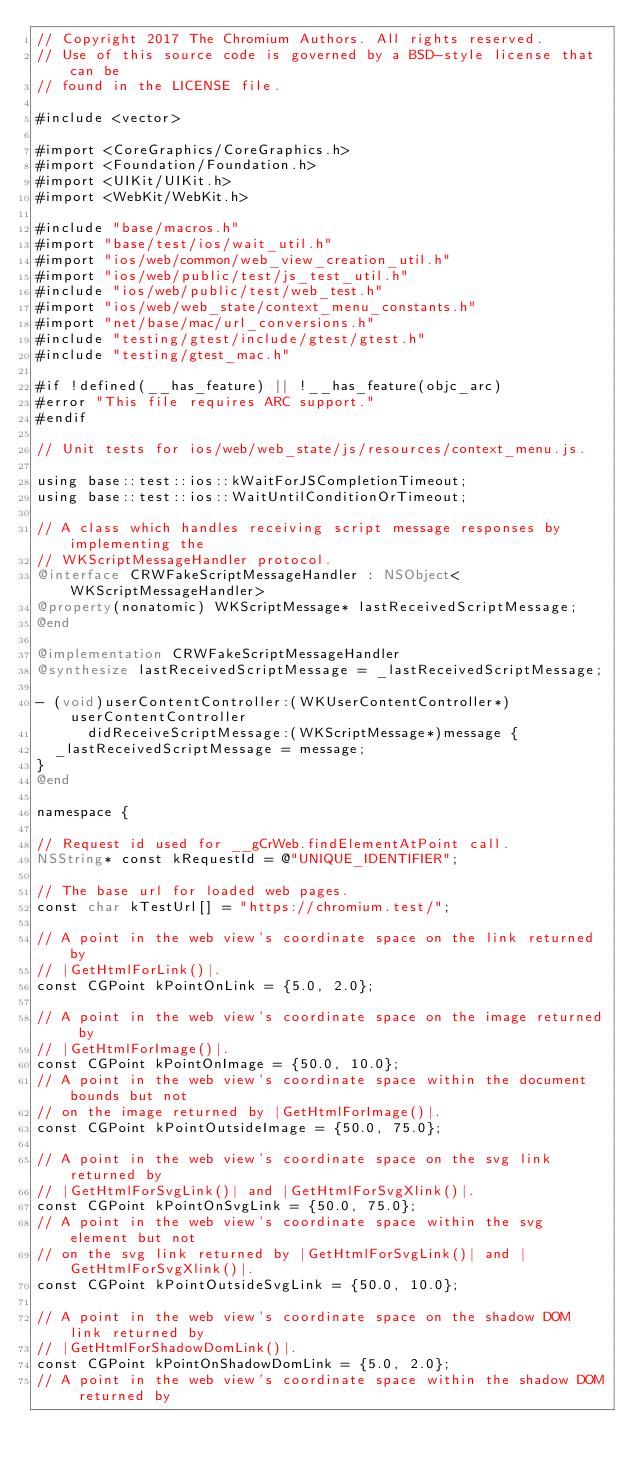<code> <loc_0><loc_0><loc_500><loc_500><_ObjectiveC_>// Copyright 2017 The Chromium Authors. All rights reserved.
// Use of this source code is governed by a BSD-style license that can be
// found in the LICENSE file.

#include <vector>

#import <CoreGraphics/CoreGraphics.h>
#import <Foundation/Foundation.h>
#import <UIKit/UIKit.h>
#import <WebKit/WebKit.h>

#include "base/macros.h"
#import "base/test/ios/wait_util.h"
#import "ios/web/common/web_view_creation_util.h"
#import "ios/web/public/test/js_test_util.h"
#include "ios/web/public/test/web_test.h"
#import "ios/web/web_state/context_menu_constants.h"
#import "net/base/mac/url_conversions.h"
#include "testing/gtest/include/gtest/gtest.h"
#include "testing/gtest_mac.h"

#if !defined(__has_feature) || !__has_feature(objc_arc)
#error "This file requires ARC support."
#endif

// Unit tests for ios/web/web_state/js/resources/context_menu.js.

using base::test::ios::kWaitForJSCompletionTimeout;
using base::test::ios::WaitUntilConditionOrTimeout;

// A class which handles receiving script message responses by implementing the
// WKScriptMessageHandler protocol.
@interface CRWFakeScriptMessageHandler : NSObject<WKScriptMessageHandler>
@property(nonatomic) WKScriptMessage* lastReceivedScriptMessage;
@end

@implementation CRWFakeScriptMessageHandler
@synthesize lastReceivedScriptMessage = _lastReceivedScriptMessage;

- (void)userContentController:(WKUserContentController*)userContentController
      didReceiveScriptMessage:(WKScriptMessage*)message {
  _lastReceivedScriptMessage = message;
}
@end

namespace {

// Request id used for __gCrWeb.findElementAtPoint call.
NSString* const kRequestId = @"UNIQUE_IDENTIFIER";

// The base url for loaded web pages.
const char kTestUrl[] = "https://chromium.test/";

// A point in the web view's coordinate space on the link returned by
// |GetHtmlForLink()|.
const CGPoint kPointOnLink = {5.0, 2.0};

// A point in the web view's coordinate space on the image returned by
// |GetHtmlForImage()|.
const CGPoint kPointOnImage = {50.0, 10.0};
// A point in the web view's coordinate space within the document bounds but not
// on the image returned by |GetHtmlForImage()|.
const CGPoint kPointOutsideImage = {50.0, 75.0};

// A point in the web view's coordinate space on the svg link returned by
// |GetHtmlForSvgLink()| and |GetHtmlForSvgXlink()|.
const CGPoint kPointOnSvgLink = {50.0, 75.0};
// A point in the web view's coordinate space within the svg element but not
// on the svg link returned by |GetHtmlForSvgLink()| and |GetHtmlForSvgXlink()|.
const CGPoint kPointOutsideSvgLink = {50.0, 10.0};

// A point in the web view's coordinate space on the shadow DOM link returned by
// |GetHtmlForShadowDomLink()|.
const CGPoint kPointOnShadowDomLink = {5.0, 2.0};
// A point in the web view's coordinate space within the shadow DOM returned by</code> 